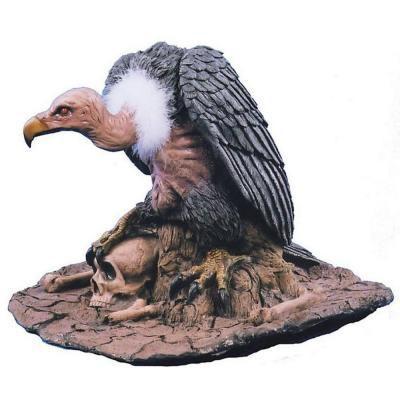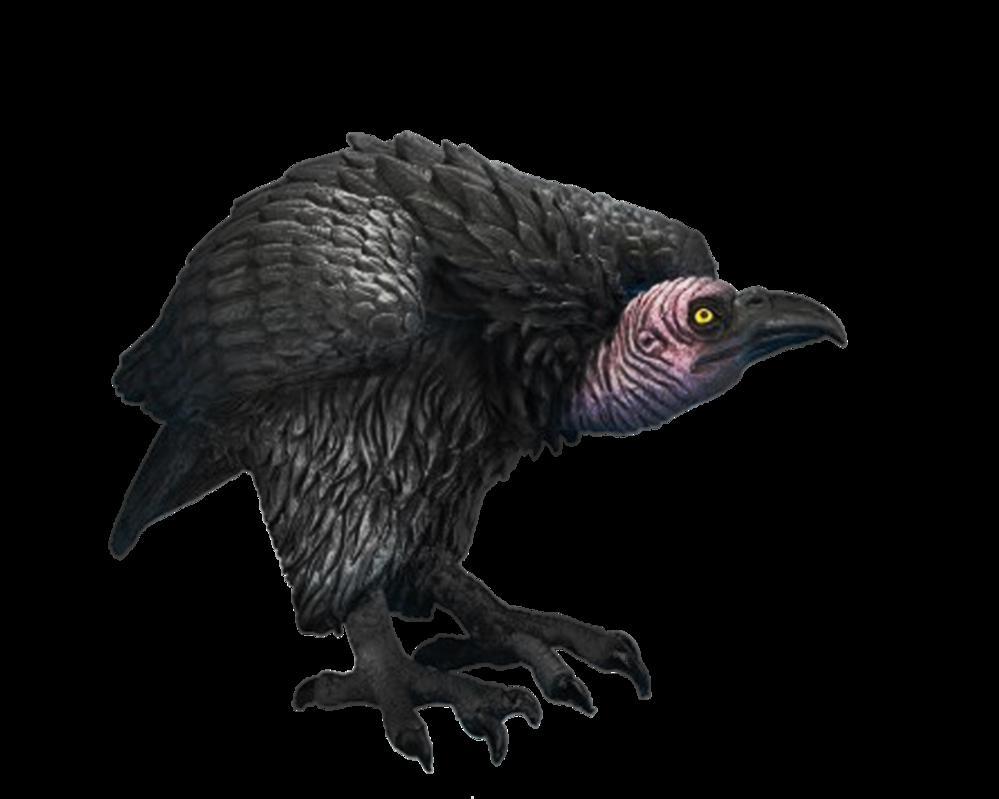The first image is the image on the left, the second image is the image on the right. Considering the images on both sides, is "There are 2 birds." valid? Answer yes or no. Yes. 